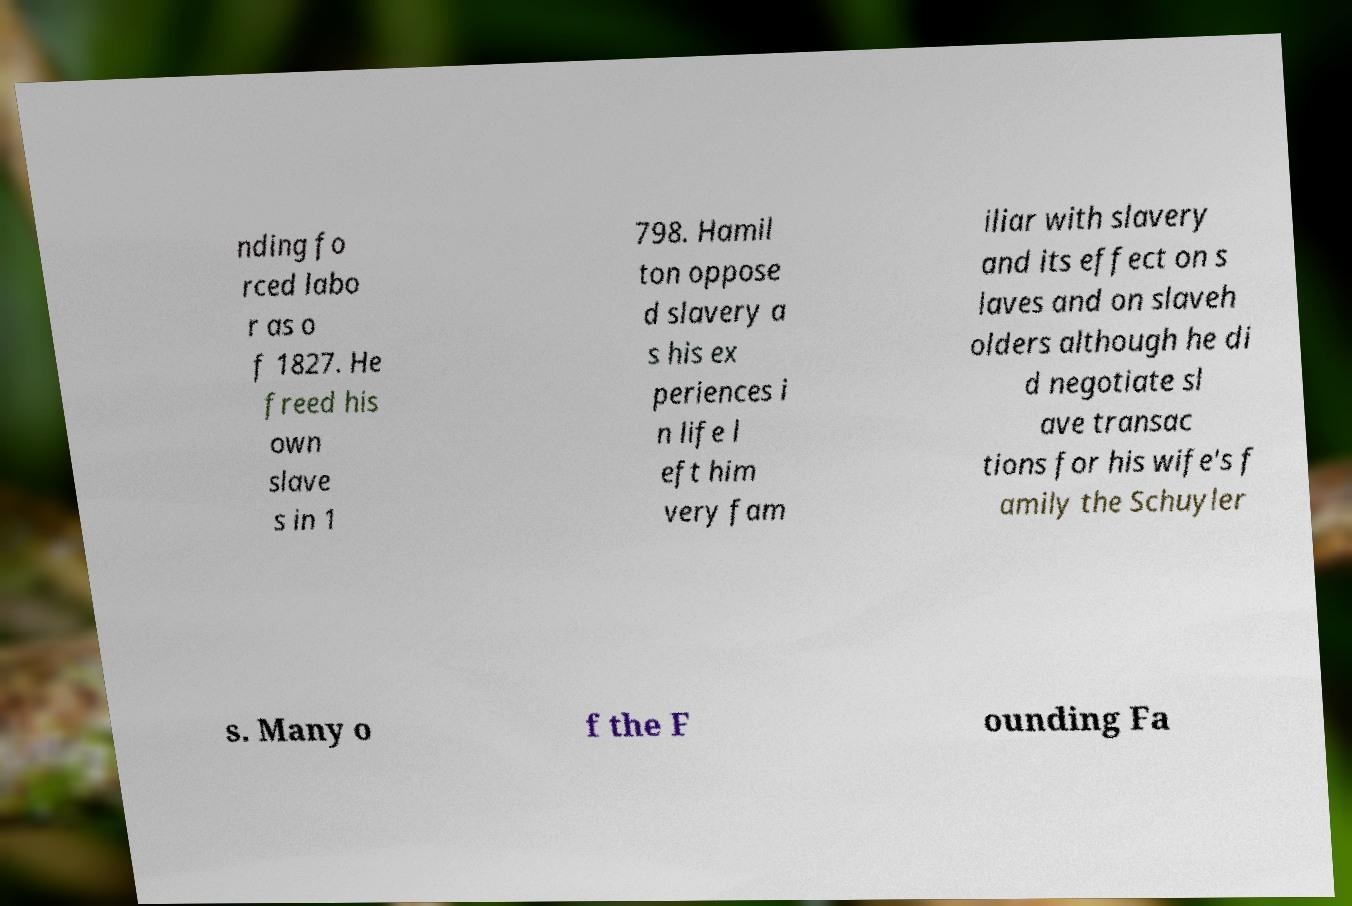Please identify and transcribe the text found in this image. nding fo rced labo r as o f 1827. He freed his own slave s in 1 798. Hamil ton oppose d slavery a s his ex periences i n life l eft him very fam iliar with slavery and its effect on s laves and on slaveh olders although he di d negotiate sl ave transac tions for his wife's f amily the Schuyler s. Many o f the F ounding Fa 